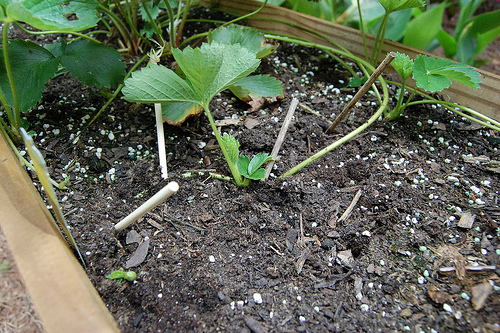<image>
Is the dirt under the plant? Yes. The dirt is positioned underneath the plant, with the plant above it in the vertical space. 